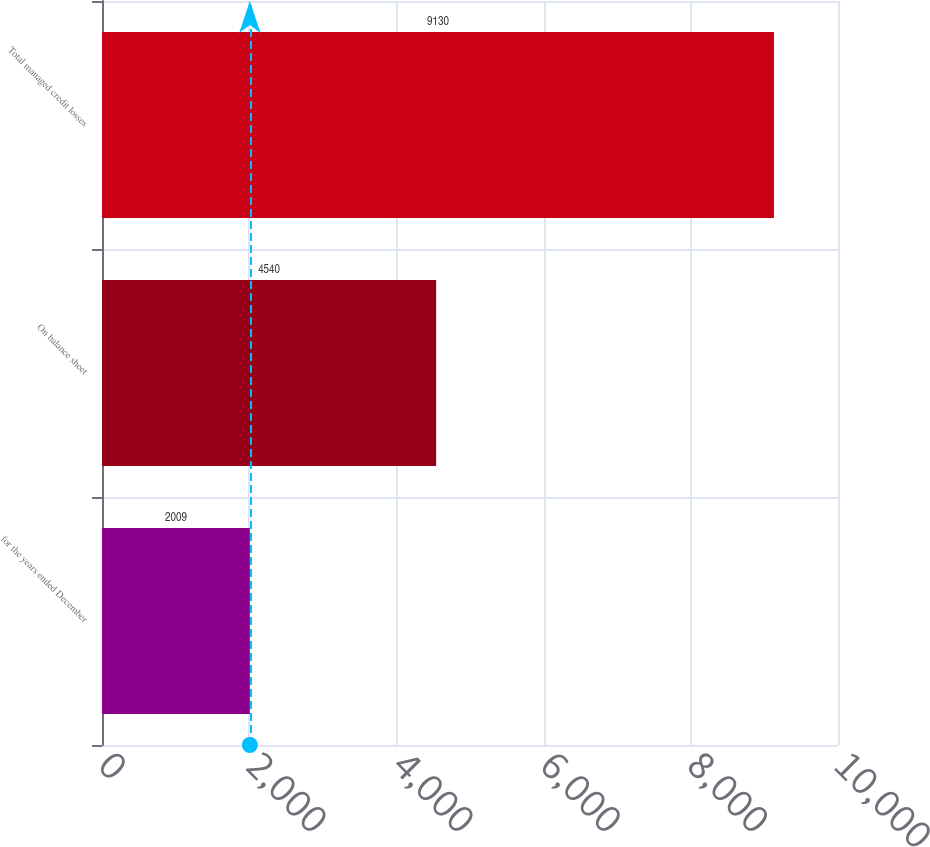<chart> <loc_0><loc_0><loc_500><loc_500><bar_chart><fcel>for the years ended December<fcel>On balance sheet<fcel>Total managed credit losses<nl><fcel>2009<fcel>4540<fcel>9130<nl></chart> 